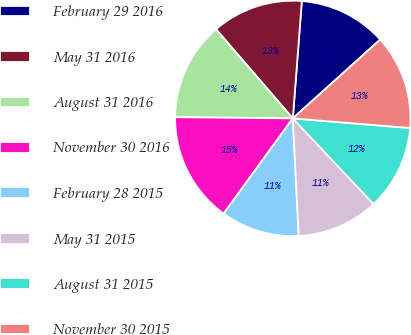Convert chart. <chart><loc_0><loc_0><loc_500><loc_500><pie_chart><fcel>February 29 2016<fcel>May 31 2016<fcel>August 31 2016<fcel>November 30 2016<fcel>February 28 2015<fcel>May 31 2015<fcel>August 31 2015<fcel>November 30 2015<nl><fcel>12.1%<fcel>12.54%<fcel>13.51%<fcel>15.17%<fcel>10.79%<fcel>11.23%<fcel>11.67%<fcel>12.98%<nl></chart> 